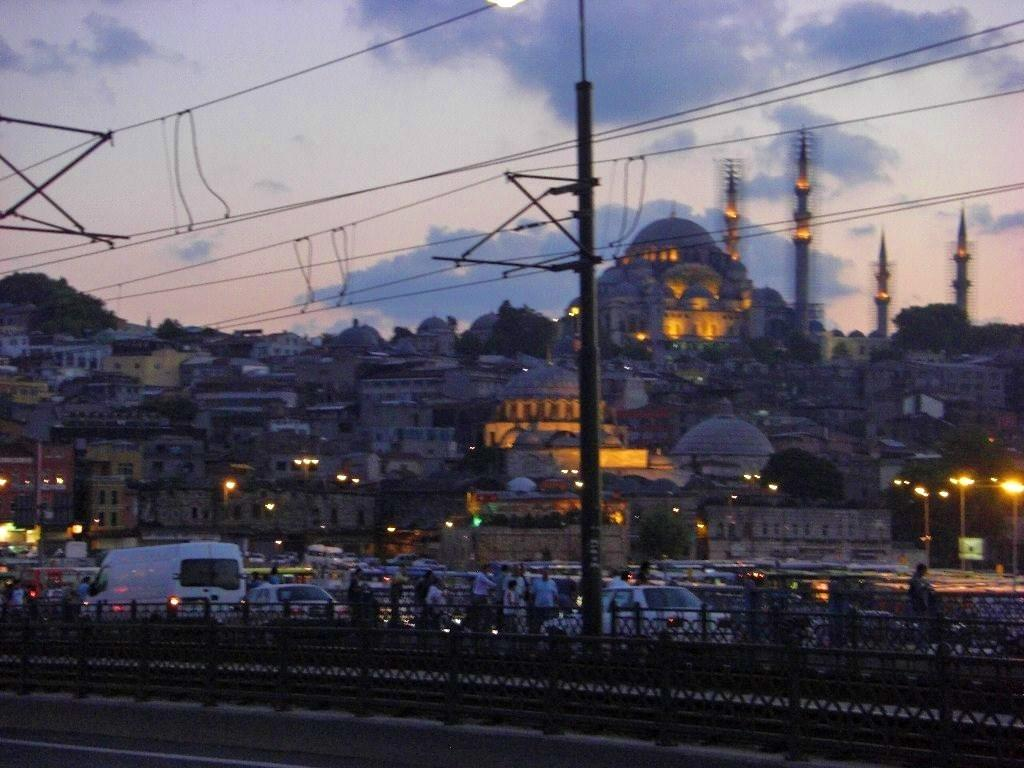What is the weather like in the image? The sky is cloudy in the image. What can be seen in the distance behind the main subject? There are buildings and trees in the background. What is happening on the road in the image? Vehicles and people are present on the road. What type of infrastructure is present in the image? There is a current pole with cables and light poles visible. What type of animals can be seen in the zoo in the image? There is no zoo present in the image; it features a cloudy sky, buildings, trees, vehicles, people, and infrastructure elements. 